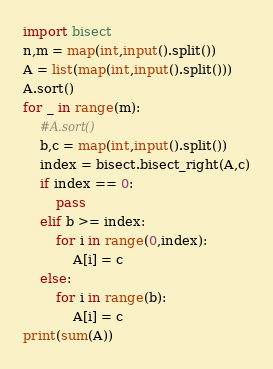<code> <loc_0><loc_0><loc_500><loc_500><_Python_>import bisect
n,m = map(int,input().split())
A = list(map(int,input().split()))
A.sort()
for _ in range(m):
    #A.sort()
    b,c = map(int,input().split())
    index = bisect.bisect_right(A,c)
    if index == 0:
        pass
    elif b >= index:
        for i in range(0,index):
            A[i] = c
    else:
        for i in range(b):
            A[i] = c
print(sum(A))</code> 